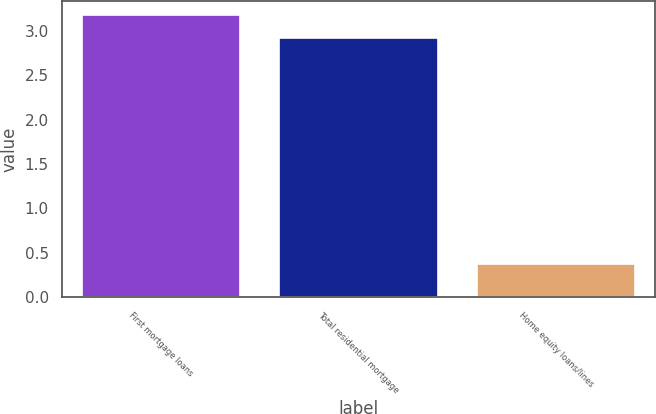Convert chart. <chart><loc_0><loc_0><loc_500><loc_500><bar_chart><fcel>First mortgage loans<fcel>Total residential mortgage<fcel>Home equity loans/lines<nl><fcel>3.18<fcel>2.92<fcel>0.37<nl></chart> 